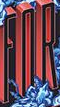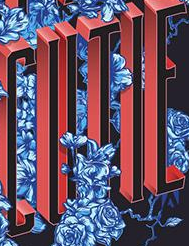Transcribe the words shown in these images in order, separated by a semicolon. FOR; CUTIE 